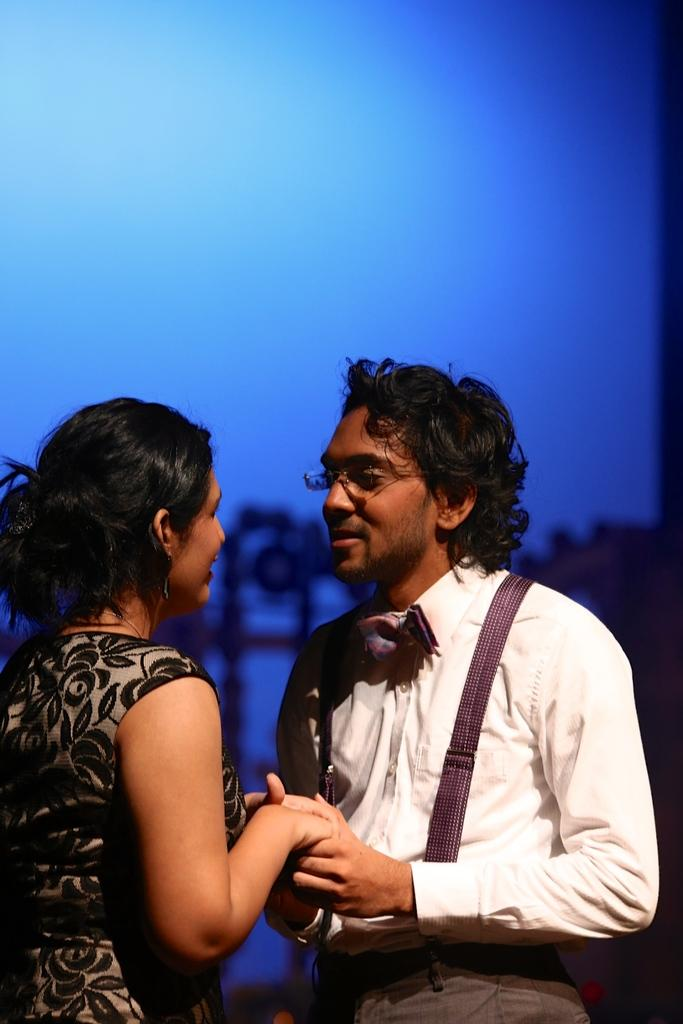How many people are in the image? There are two persons in the image. What are the two persons doing in the image? The two persons are facing each other. What can be seen in the background of the image? The sky is visible in the background of the image. What rate of exchange are the two persons discussing in the image? There is no indication in the image that the two persons are discussing any rate of exchange. 